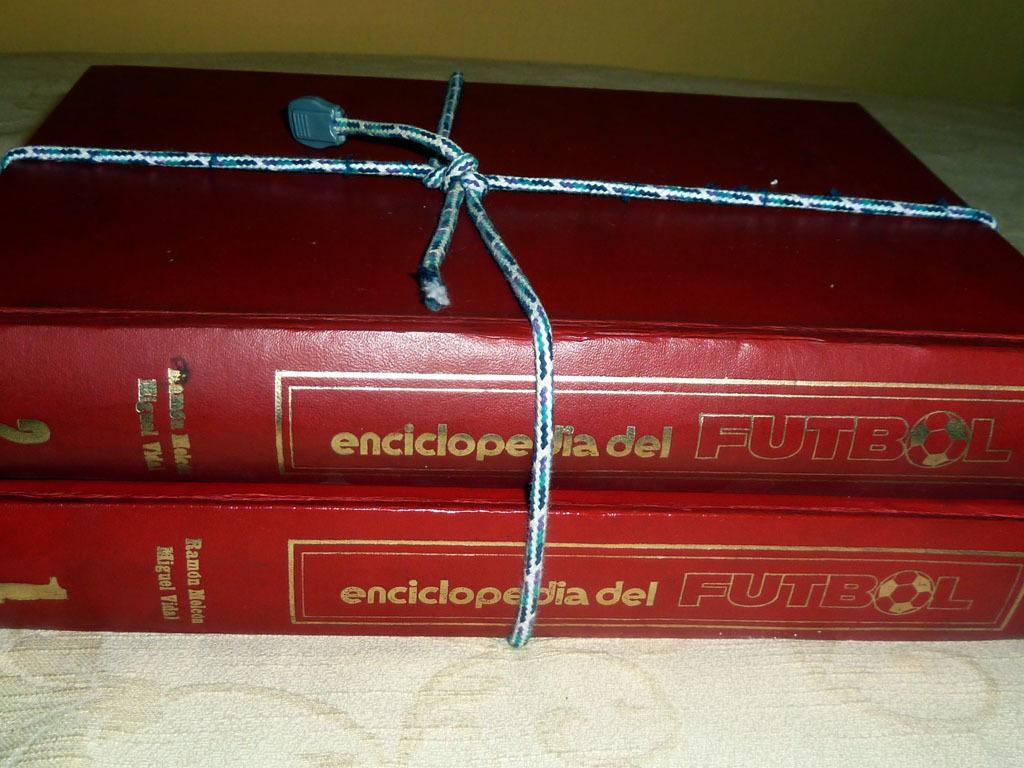Please provide a concise description of this image. In this image we can see books placed on the table. In the background there is a wall. 